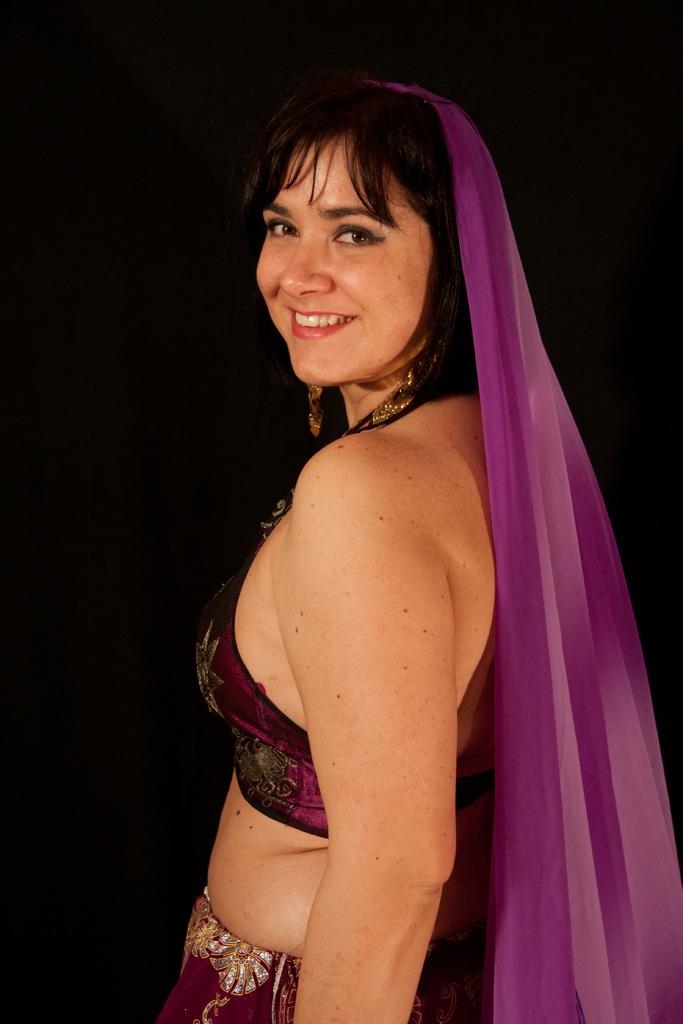Who is present in the image? There is a woman in the image. What is the woman's facial expression? The woman is smiling. What can be observed about the background of the image? The background of the image is dark. What type of spade is the woman using in the image? There is no spade present in the image. Can you see any farm animals in the image? There are no farm animals present in the image. 